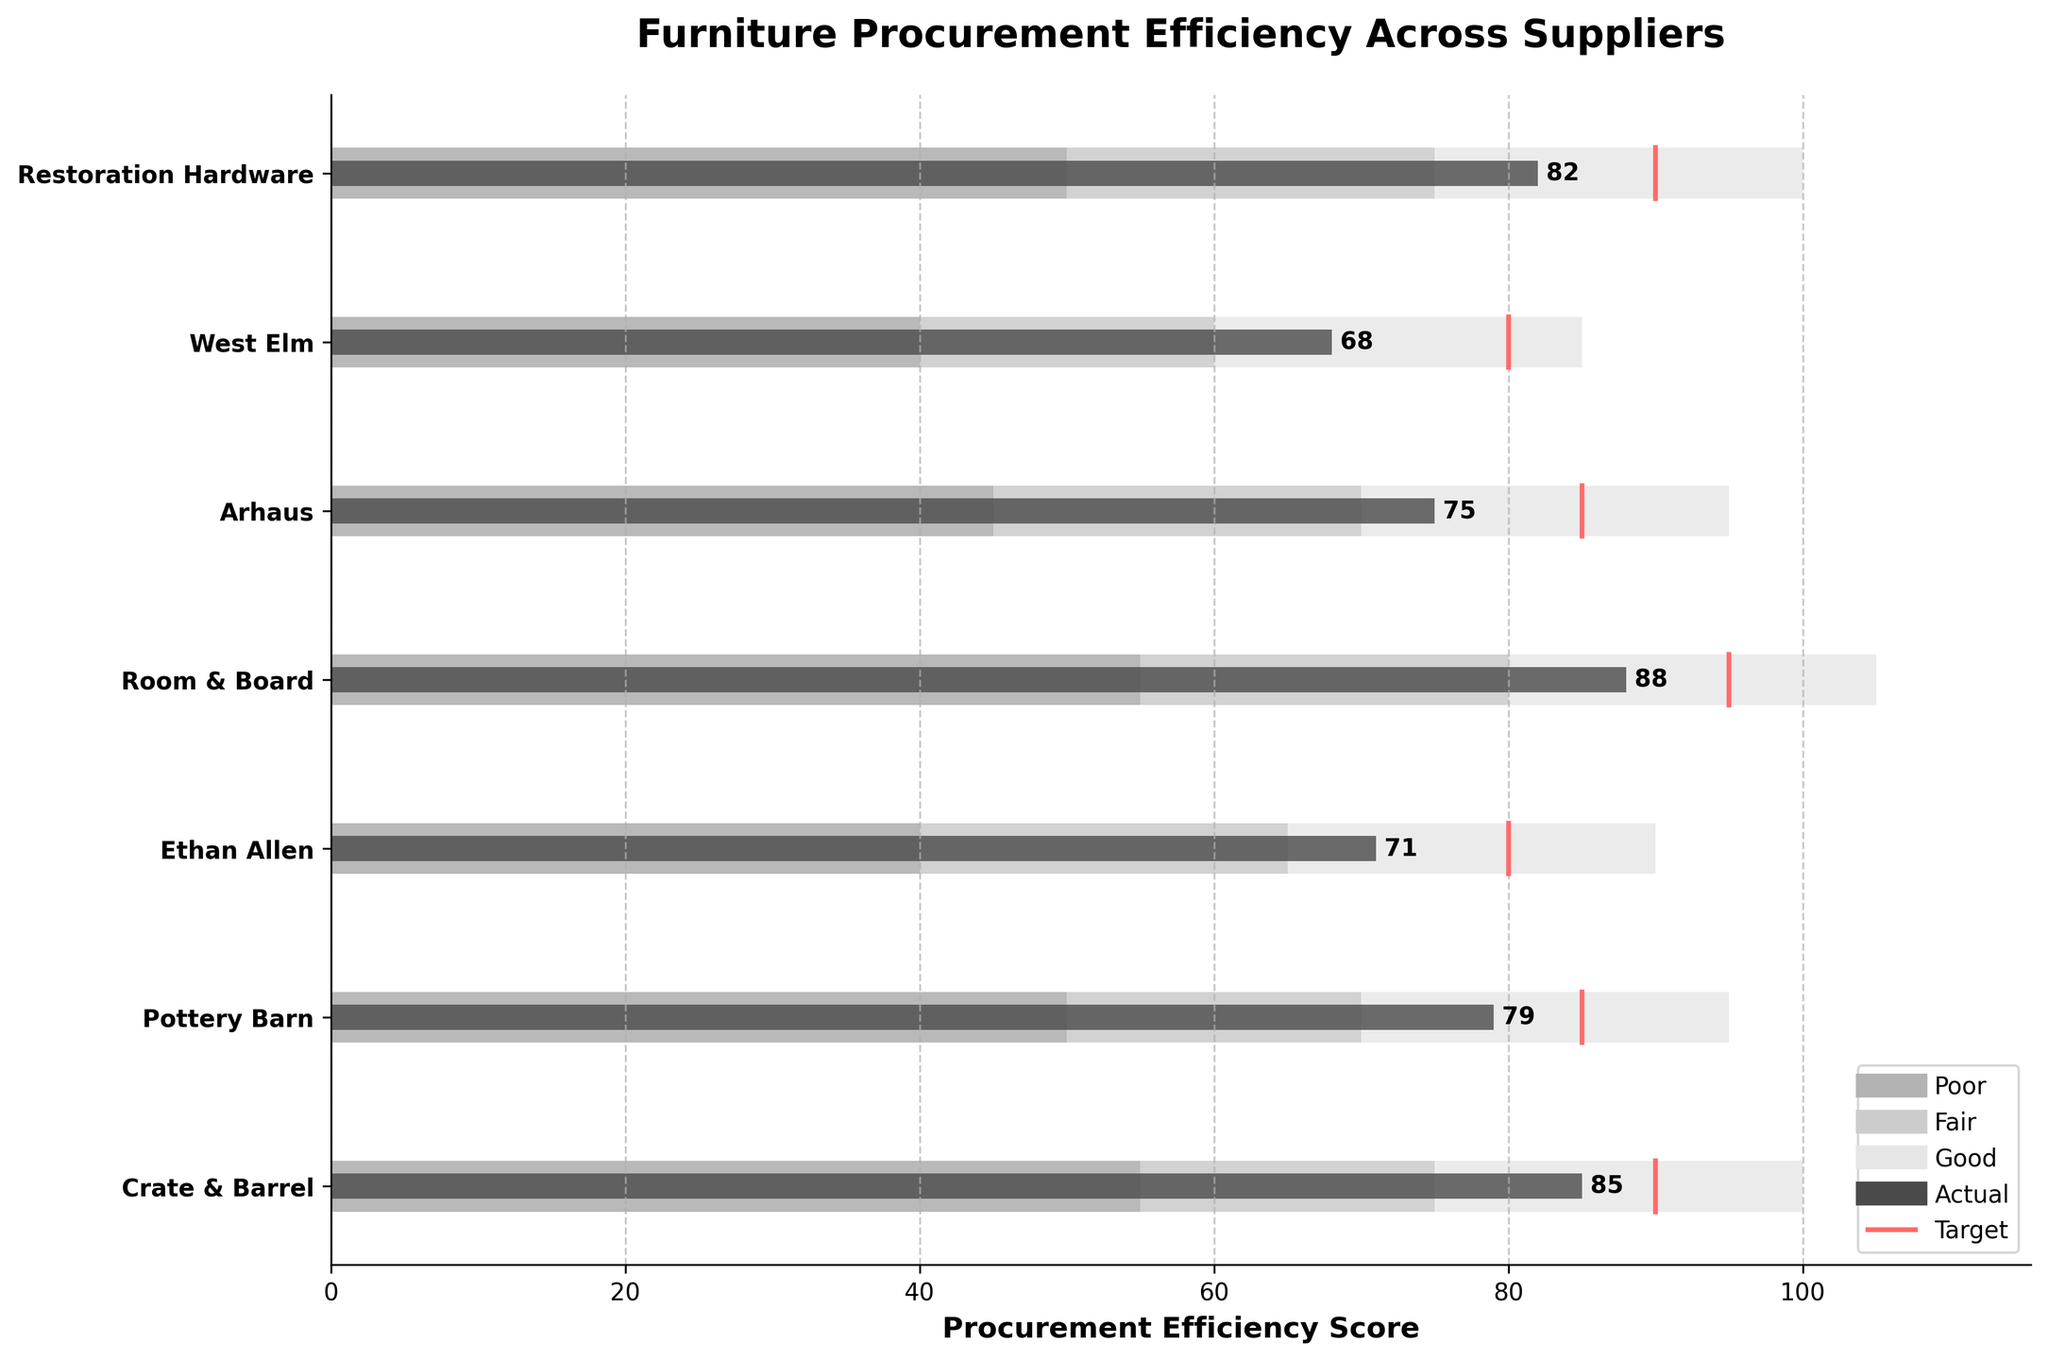what is the title of the chart? The title is located at the top of the chart and describes the content.
Answer: Furniture Procurement Efficiency Across Suppliers How many suppliers are evaluated in the chart? By counting the names of the suppliers on the y-axis, you can see there are seven suppliers.
Answer: Seven Which supplier has the highest procurement efficiency score? Look for the highest actual score represented by the dark bars. Room & Board shows the highest score of 88.
Answer: Room & Board What is the difference between the target and actual efficiency scores for Restoration Hardware? Subtract the actual score from the target score for Restoration Hardware, i.e., 90 - 82.
Answer: 8 Which suppliers met or exceeded their target efficiency score? Compare the actual scores to the target scores for each supplier and identify those where the actual score is equal to or greater than the target. Room & Board and Crate & Barrel met or exceeded their targets.
Answer: Room & Board, Crate & Barrel Which supplier has the largest gap between their actual and target efficiency scores? Calculate the gaps for each supplier by subtracting the actual score from the target score and find the largest gap. West Elm has the largest gap of 12 (80 - 68).
Answer: West Elm How many suppliers fall within the 'Good' range of procurement efficiency? Check the color-coded bars (lightest gray) indicating the 'Good' range for each supplier. Then count how many suppliers' actual scores (dark bars) fall within these ranges. Five suppliers fall within the 'Good' range.
Answer: Five What percentage of suppliers achieved or surpassed 85 in their procurement efficiency score? Identify the suppliers with a score of 85 or more, then divide by the total number of suppliers and multiply by 100. For 2 suppliers out of 7, the calculation is (2/7) * 100.
Answer: Approximately 28.57% Which supplier has the smallest range for the 'Good' efficiency level, and what is that range? Determine the 'Good' range for each supplier by subtracting Range1 from Range3 and identify the smallest range. West Elm has the smallest 'Good' range of 45 (85 - 40).
Answer: West Elm, 45 